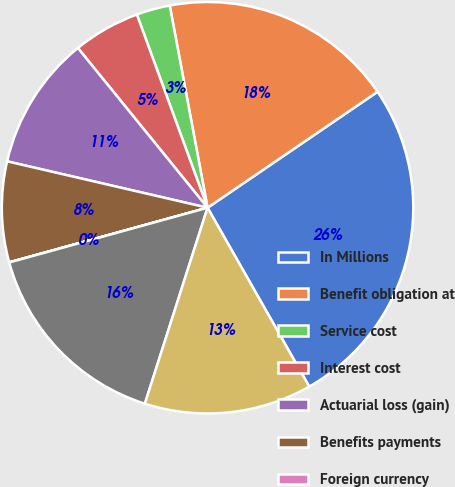Convert chart to OTSL. <chart><loc_0><loc_0><loc_500><loc_500><pie_chart><fcel>In Millions<fcel>Benefit obligation at<fcel>Service cost<fcel>Interest cost<fcel>Actuarial loss (gain)<fcel>Benefits payments<fcel>Foreign currency<fcel>Projected benefit obligation<fcel>Plan assets less than benefit<nl><fcel>26.31%<fcel>18.42%<fcel>2.64%<fcel>5.27%<fcel>10.53%<fcel>7.9%<fcel>0.01%<fcel>15.79%<fcel>13.16%<nl></chart> 